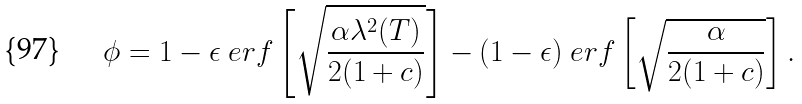Convert formula to latex. <formula><loc_0><loc_0><loc_500><loc_500>\phi = 1 - \epsilon \ e r f \left [ \sqrt { \frac { \alpha \lambda ^ { 2 } ( T ) } { 2 ( 1 + c ) } } \right ] - ( 1 - \epsilon ) \ e r f \left [ \sqrt { \frac { \alpha } { 2 ( 1 + c ) } } \right ] .</formula> 